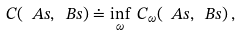Convert formula to latex. <formula><loc_0><loc_0><loc_500><loc_500>C ( \ A s , \ B s ) \doteq \inf _ { \omega } \, C _ { \omega } ( \ A s , \ B s ) \, ,</formula> 